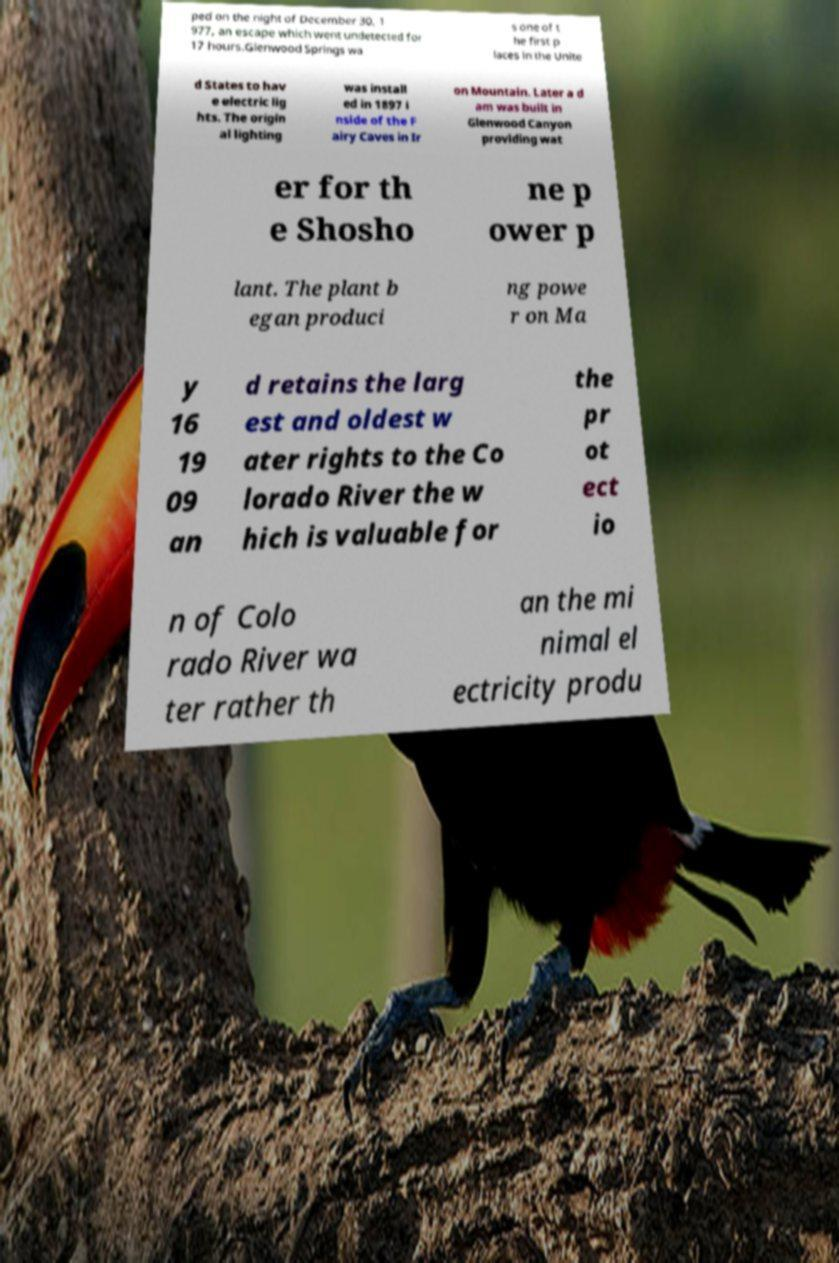I need the written content from this picture converted into text. Can you do that? ped on the night of December 30, 1 977, an escape which went undetected for 17 hours.Glenwood Springs wa s one of t he first p laces in the Unite d States to hav e electric lig hts. The origin al lighting was install ed in 1897 i nside of the F airy Caves in Ir on Mountain. Later a d am was built in Glenwood Canyon providing wat er for th e Shosho ne p ower p lant. The plant b egan produci ng powe r on Ma y 16 19 09 an d retains the larg est and oldest w ater rights to the Co lorado River the w hich is valuable for the pr ot ect io n of Colo rado River wa ter rather th an the mi nimal el ectricity produ 